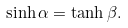Convert formula to latex. <formula><loc_0><loc_0><loc_500><loc_500>\sinh \alpha = \tanh \beta .</formula> 